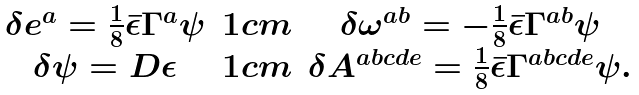Convert formula to latex. <formula><loc_0><loc_0><loc_500><loc_500>\begin{array} { c c c } \delta e ^ { a } = \frac { 1 } { 8 } \bar { \epsilon } \Gamma ^ { a } \psi & 1 c m & \delta \omega ^ { a b } = - \frac { 1 } { 8 } \bar { \epsilon } \Gamma ^ { a b } \psi \\ \delta \psi = D \epsilon & 1 c m & \delta A ^ { a b c d e } = \frac { 1 } { 8 } \bar { \epsilon } \Gamma ^ { a b c d e } \psi . \end{array}</formula> 